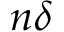Convert formula to latex. <formula><loc_0><loc_0><loc_500><loc_500>n \delta</formula> 